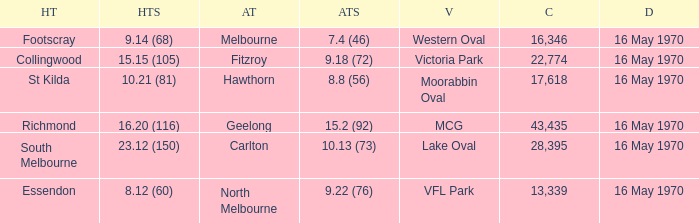What away team scored 9.18 (72)? Fitzroy. 